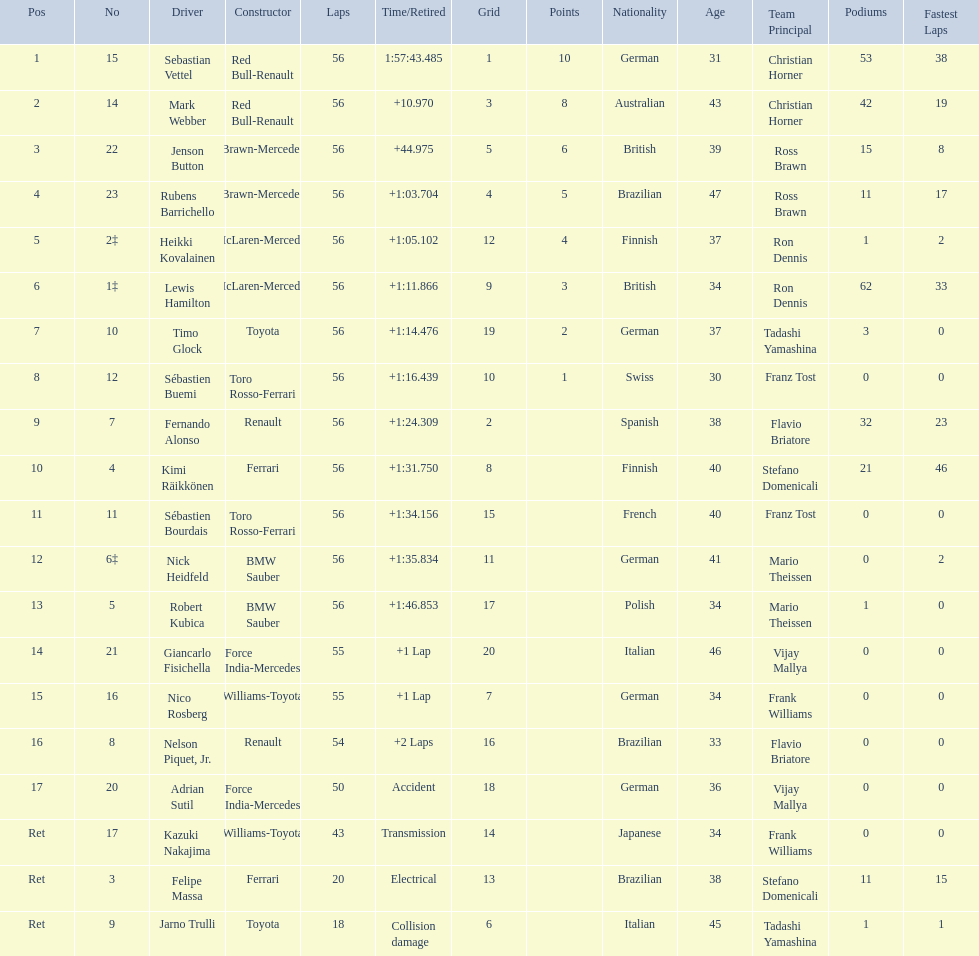Who were all of the drivers in the 2009 chinese grand prix? Sebastian Vettel, Mark Webber, Jenson Button, Rubens Barrichello, Heikki Kovalainen, Lewis Hamilton, Timo Glock, Sébastien Buemi, Fernando Alonso, Kimi Räikkönen, Sébastien Bourdais, Nick Heidfeld, Robert Kubica, Giancarlo Fisichella, Nico Rosberg, Nelson Piquet, Jr., Adrian Sutil, Kazuki Nakajima, Felipe Massa, Jarno Trulli. And what were their finishing times? 1:57:43.485, +10.970, +44.975, +1:03.704, +1:05.102, +1:11.866, +1:14.476, +1:16.439, +1:24.309, +1:31.750, +1:34.156, +1:35.834, +1:46.853, +1 Lap, +1 Lap, +2 Laps, Accident, Transmission, Electrical, Collision damage. Which player faced collision damage and retired from the race? Jarno Trulli. Would you be able to parse every entry in this table? {'header': ['Pos', 'No', 'Driver', 'Constructor', 'Laps', 'Time/Retired', 'Grid', 'Points', 'Nationality', 'Age', 'Team Principal', 'Podiums', 'Fastest Laps'], 'rows': [['1', '15', 'Sebastian Vettel', 'Red Bull-Renault', '56', '1:57:43.485', '1', '10', 'German', '31', 'Christian Horner', '53', '38'], ['2', '14', 'Mark Webber', 'Red Bull-Renault', '56', '+10.970', '3', '8', 'Australian', '43', 'Christian Horner', '42', '19'], ['3', '22', 'Jenson Button', 'Brawn-Mercedes', '56', '+44.975', '5', '6', 'British', '39', 'Ross Brawn', '15', '8'], ['4', '23', 'Rubens Barrichello', 'Brawn-Mercedes', '56', '+1:03.704', '4', '5', 'Brazilian', '47', 'Ross Brawn', '11', '17'], ['5', '2‡', 'Heikki Kovalainen', 'McLaren-Mercedes', '56', '+1:05.102', '12', '4', 'Finnish', '37', 'Ron Dennis', '1', '2'], ['6', '1‡', 'Lewis Hamilton', 'McLaren-Mercedes', '56', '+1:11.866', '9', '3', 'British', '34', 'Ron Dennis', '62', '33'], ['7', '10', 'Timo Glock', 'Toyota', '56', '+1:14.476', '19', '2', 'German', '37', 'Tadashi Yamashina', '3', '0'], ['8', '12', 'Sébastien Buemi', 'Toro Rosso-Ferrari', '56', '+1:16.439', '10', '1', 'Swiss', '30', 'Franz Tost', '0', '0'], ['9', '7', 'Fernando Alonso', 'Renault', '56', '+1:24.309', '2', '', 'Spanish', '38', 'Flavio Briatore', '32', '23'], ['10', '4', 'Kimi Räikkönen', 'Ferrari', '56', '+1:31.750', '8', '', 'Finnish', '40', 'Stefano Domenicali', '21', '46'], ['11', '11', 'Sébastien Bourdais', 'Toro Rosso-Ferrari', '56', '+1:34.156', '15', '', 'French', '40', 'Franz Tost', '0', '0'], ['12', '6‡', 'Nick Heidfeld', 'BMW Sauber', '56', '+1:35.834', '11', '', 'German', '41', 'Mario Theissen', '0', '2'], ['13', '5', 'Robert Kubica', 'BMW Sauber', '56', '+1:46.853', '17', '', 'Polish', '34', 'Mario Theissen', '1', '0'], ['14', '21', 'Giancarlo Fisichella', 'Force India-Mercedes', '55', '+1 Lap', '20', '', 'Italian', '46', 'Vijay Mallya', '0', '0'], ['15', '16', 'Nico Rosberg', 'Williams-Toyota', '55', '+1 Lap', '7', '', 'German', '34', 'Frank Williams', '0', '0'], ['16', '8', 'Nelson Piquet, Jr.', 'Renault', '54', '+2 Laps', '16', '', 'Brazilian', '33', 'Flavio Briatore', '0', '0'], ['17', '20', 'Adrian Sutil', 'Force India-Mercedes', '50', 'Accident', '18', '', 'German', '36', 'Vijay Mallya', '0', '0'], ['Ret', '17', 'Kazuki Nakajima', 'Williams-Toyota', '43', 'Transmission', '14', '', 'Japanese', '34', 'Frank Williams', '0', '0'], ['Ret', '3', 'Felipe Massa', 'Ferrari', '20', 'Electrical', '13', '', 'Brazilian', '38', 'Stefano Domenicali', '11', '15'], ['Ret', '9', 'Jarno Trulli', 'Toyota', '18', 'Collision damage', '6', '', 'Italian', '45', 'Tadashi Yamashina', '1', '1']]} 